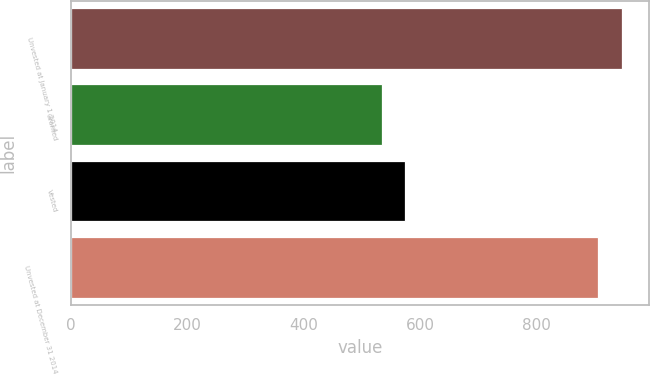Convert chart to OTSL. <chart><loc_0><loc_0><loc_500><loc_500><bar_chart><fcel>Unvested at January 1 2014<fcel>Granted<fcel>Vested<fcel>Unvested at December 31 2014<nl><fcel>946.7<fcel>534<fcel>574.7<fcel>906<nl></chart> 